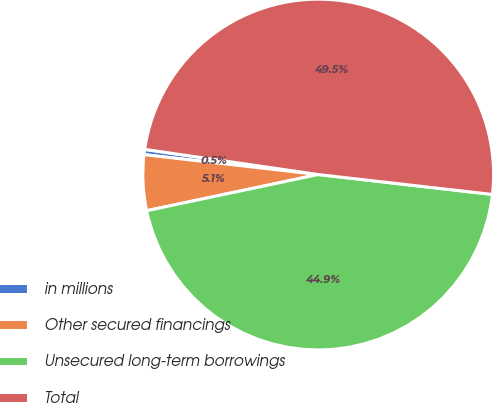<chart> <loc_0><loc_0><loc_500><loc_500><pie_chart><fcel>in millions<fcel>Other secured financings<fcel>Unsecured long-term borrowings<fcel>Total<nl><fcel>0.48%<fcel>5.12%<fcel>44.88%<fcel>49.52%<nl></chart> 